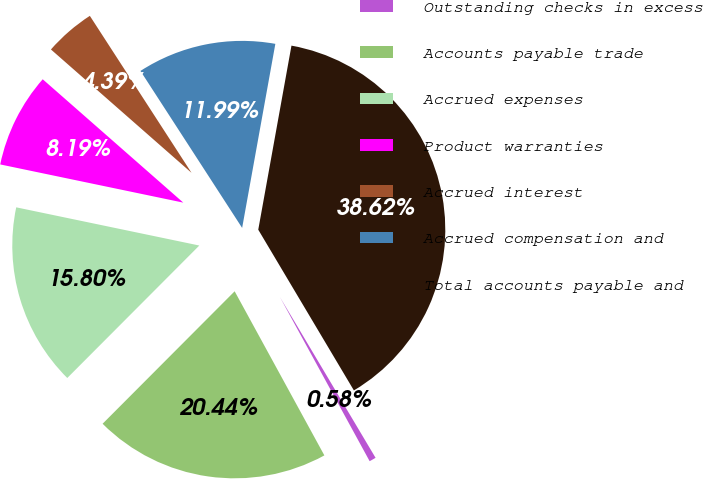<chart> <loc_0><loc_0><loc_500><loc_500><pie_chart><fcel>Outstanding checks in excess<fcel>Accounts payable trade<fcel>Accrued expenses<fcel>Product warranties<fcel>Accrued interest<fcel>Accrued compensation and<fcel>Total accounts payable and<nl><fcel>0.58%<fcel>20.44%<fcel>15.8%<fcel>8.19%<fcel>4.39%<fcel>11.99%<fcel>38.62%<nl></chart> 